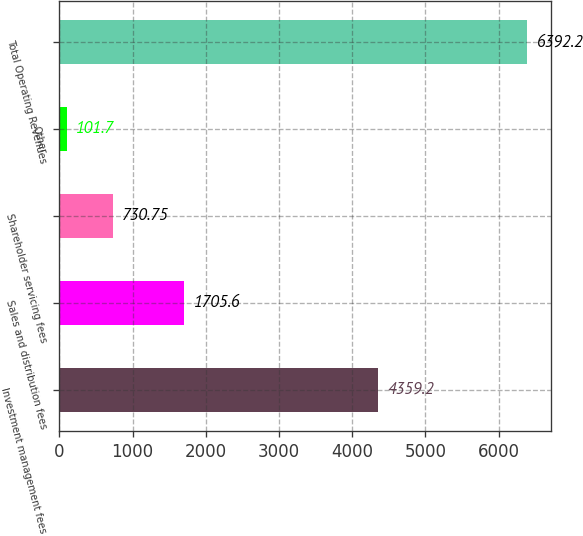<chart> <loc_0><loc_0><loc_500><loc_500><bar_chart><fcel>Investment management fees<fcel>Sales and distribution fees<fcel>Shareholder servicing fees<fcel>Other<fcel>Total Operating Revenues<nl><fcel>4359.2<fcel>1705.6<fcel>730.75<fcel>101.7<fcel>6392.2<nl></chart> 